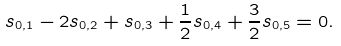Convert formula to latex. <formula><loc_0><loc_0><loc_500><loc_500>s _ { 0 , 1 } - 2 s _ { 0 , 2 } + s _ { 0 , 3 } + \frac { 1 } { 2 } s _ { 0 , 4 } + \frac { 3 } { 2 } s _ { 0 , 5 } = 0 .</formula> 